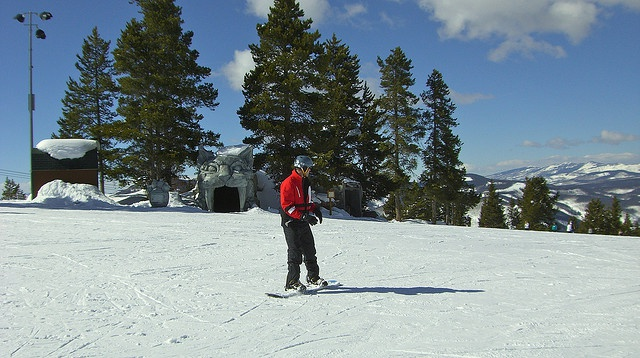Describe the objects in this image and their specific colors. I can see people in gray, black, maroon, and lightgray tones, snowboard in gray, lightgray, darkgray, and black tones, and people in gray, black, and teal tones in this image. 